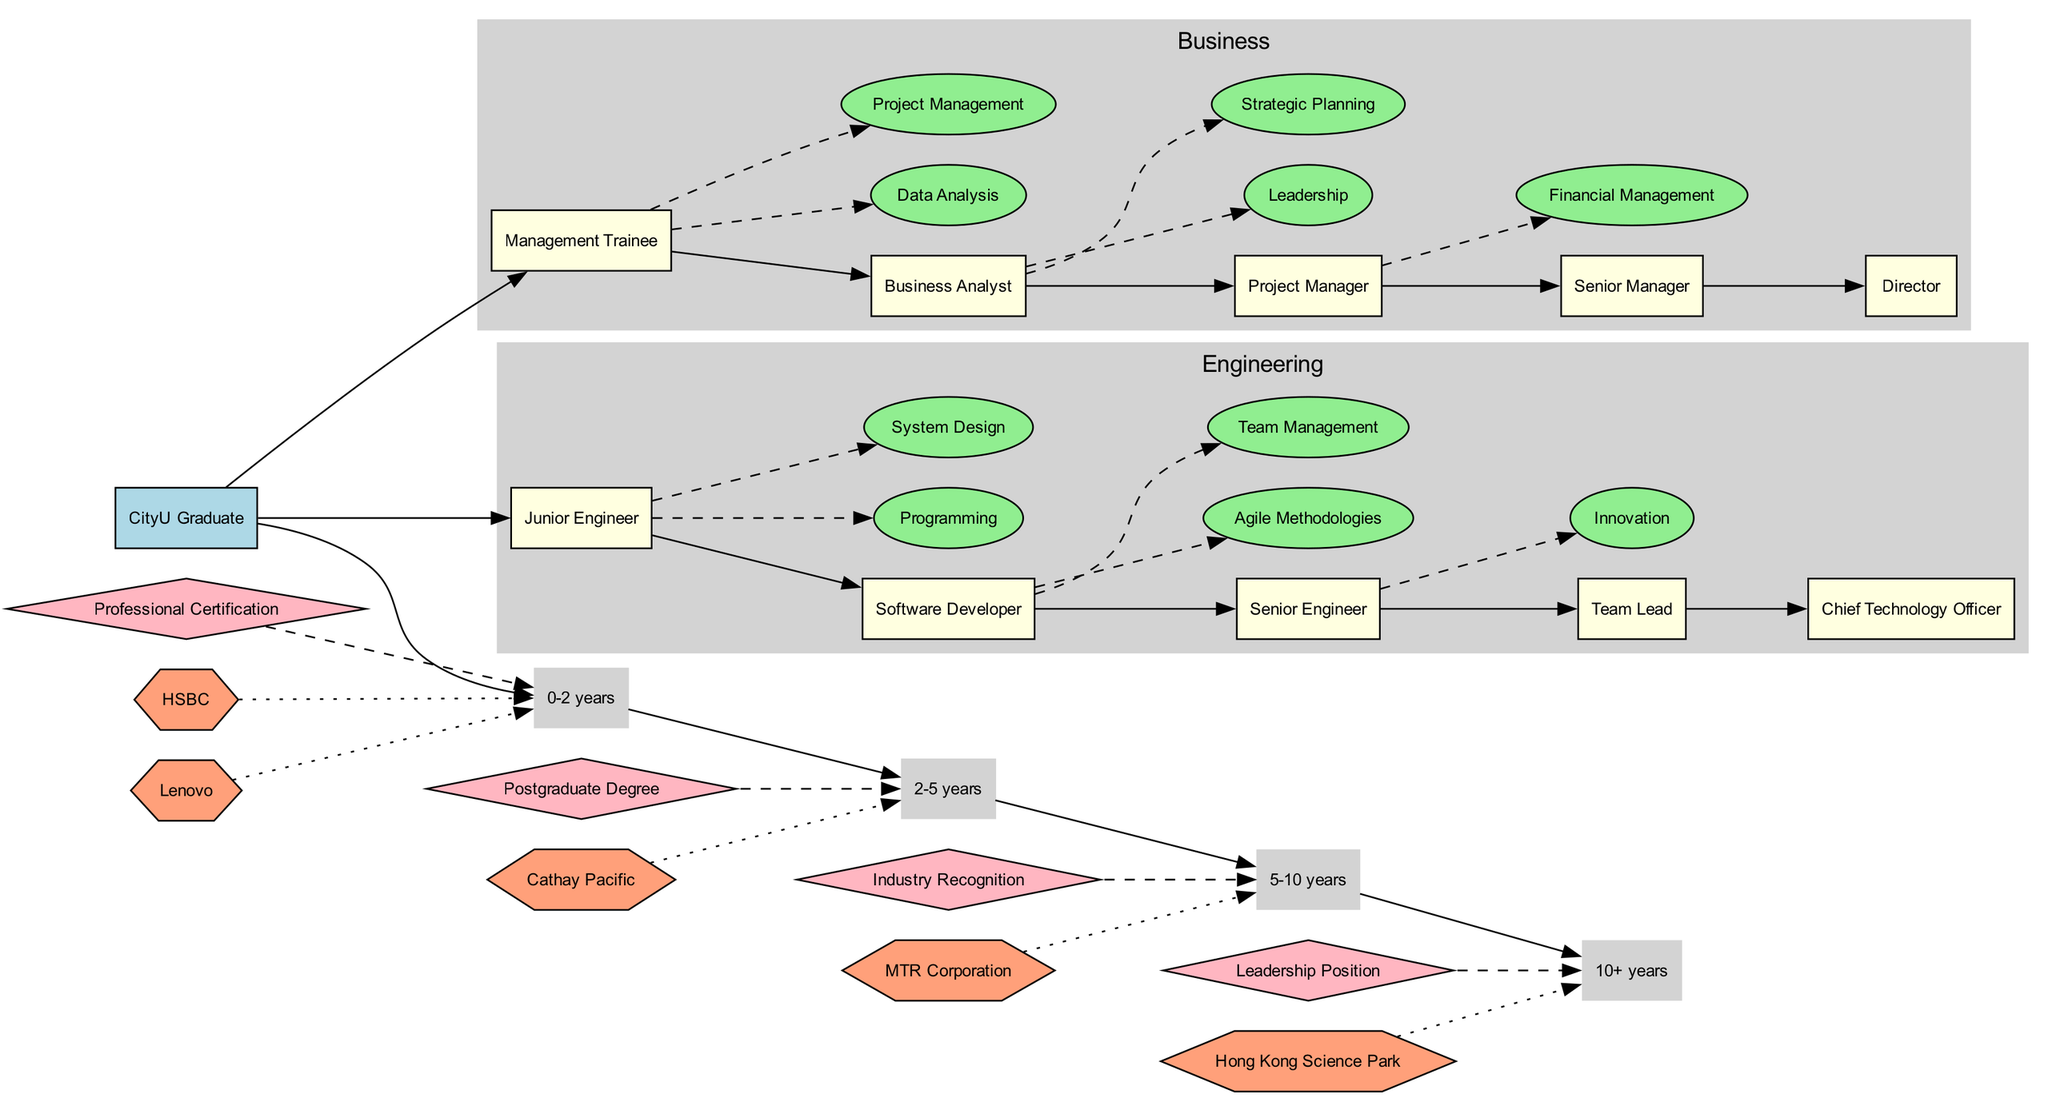What is the starting point of the career roadmap? The starting point is labeled as "CityU Graduate" in the diagram, indicating the beginning of the career journey.
Answer: CityU Graduate How many career paths are outlined in the diagram? There are two career paths presented in the diagram: Business and Engineering, which are the only fields specified.
Answer: 2 What role comes immediately after "Junior Engineer" in the Engineering field? The role that follows "Junior Engineer" is "Software Developer" as indicated by the sequential arrangement of roles in the Engineering path.
Answer: Software Developer Which skill is connected to the "Senior Engineer" role? The skill linked to "Senior Engineer" is "Team Management," which is shown to be related through a dashed line in the Engineering cluster.
Answer: Team Management What milestone is linked to the timeline at "2-5 years"? The milestone associated with the "2-5 years" timeline is "Professional Certification," as there is a dashed line connecting the milestone to that specific time segment.
Answer: Professional Certification What type of companies are represented in the diagram? The diagram includes various companies represented as hexagons, indicating they are potential employers for the graduate in their career journey.
Answer: Potential Employers Which role is the last one in the Business field? The last role in the Business field is designated as "Director," representing the highest position on the outlined path for Business graduates.
Answer: Director How many years does it take to reach a "Leadership Position"? To reach the milestone of "Leadership Position," it typically takes "10+" years as indicated in the timeline associated with milestones.
Answer: 10+ years What is the primary skill required for a "Business Analyst"? The primary skill for a "Business Analyst," as inferred from the connections in the diagram, is "Data Analysis," which is essential for this role.
Answer: Data Analysis 